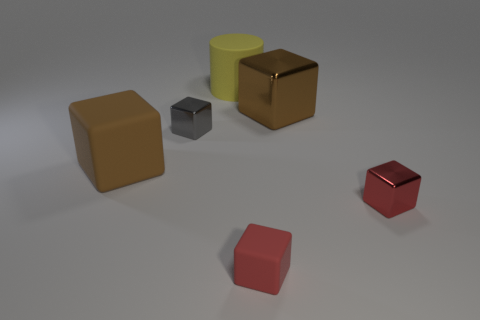What number of other objects are the same shape as the small gray object?
Provide a succinct answer. 4. What is the color of the rubber cube that is the same size as the red metal object?
Your answer should be very brief. Red. Are there an equal number of small red rubber objects that are right of the large yellow matte cylinder and blue rubber spheres?
Provide a succinct answer. No. There is a thing that is in front of the tiny gray metallic thing and left of the large yellow matte thing; what shape is it?
Provide a succinct answer. Cube. Is the matte cylinder the same size as the brown rubber cube?
Your response must be concise. Yes. Is there a green sphere that has the same material as the tiny gray block?
Provide a succinct answer. No. What is the size of the object that is the same color as the big matte block?
Provide a succinct answer. Large. What number of big objects are to the left of the gray shiny block and to the right of the small matte thing?
Give a very brief answer. 0. What material is the brown thing right of the tiny gray shiny block?
Offer a terse response. Metal. How many big matte cylinders are the same color as the large metal block?
Offer a very short reply. 0. 